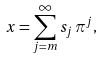Convert formula to latex. <formula><loc_0><loc_0><loc_500><loc_500>x = \sum _ { j = m } ^ { \infty } s _ { j } \, \pi ^ { j } ,</formula> 